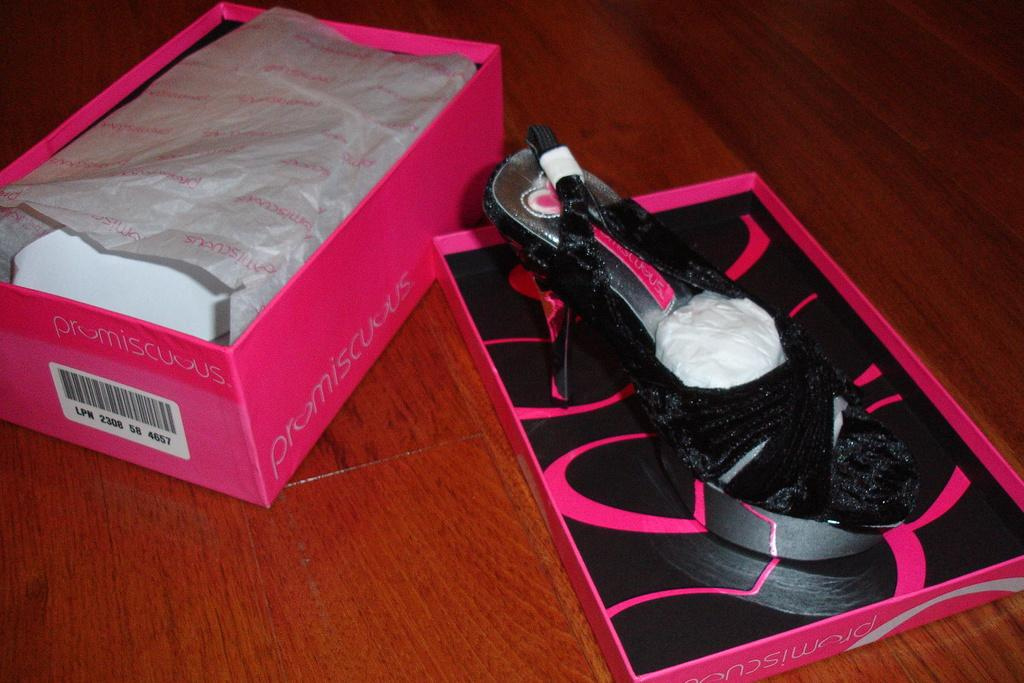What type of footwear is present in the image? There is a sandal in the image. Is there any storage for the sandal in the image? Yes, there is a box for the sandal in the image. Where are the sandal and its box located? The sandal and its box are placed on a table. What type of honey is being stored in the box next to the sandal? There is no honey present in the image; it features a sandal and its box on a table. 